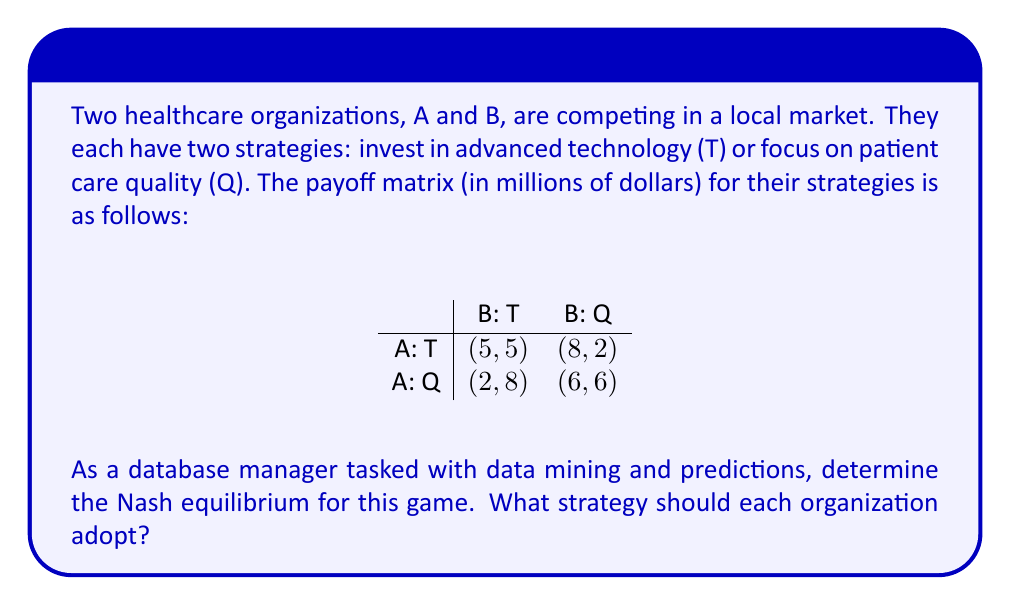Give your solution to this math problem. To find the Nash equilibrium, we need to analyze each player's best response to the other player's strategy:

1. For Organization A:
   - If B chooses T: A's best response is T (5 > 2)
   - If B chooses Q: A's best response is T (8 > 6)

2. For Organization B:
   - If A chooses T: B's best response is T (5 > 2)
   - If A chooses Q: B's best response is T (8 > 6)

A Nash equilibrium occurs when each player is making the best decision for themselves, given what the other player is doing. In this case, we can see that regardless of what the other organization does, both A and B always prefer strategy T (investing in advanced technology).

Therefore, the Nash equilibrium is (T, T), where both organizations invest in advanced technology, resulting in a payoff of (5, 5).

This equilibrium can be verified by checking that neither player has an incentive to unilaterally deviate from this strategy:
- If A switches to Q while B stays with T, A's payoff decreases from 5 to 2.
- If B switches to Q while A stays with T, B's payoff decreases from 5 to 2.

As a database manager, this analysis can help in predicting market trends and informing strategic decisions for your healthcare organization. It suggests that in this competitive market, investing in advanced technology is likely to be the dominant strategy for healthcare providers.
Answer: The Nash equilibrium is (T, T), where both organizations invest in advanced technology, resulting in a payoff of (5, 5) million dollars for each organization. 